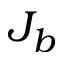<formula> <loc_0><loc_0><loc_500><loc_500>J _ { b }</formula> 